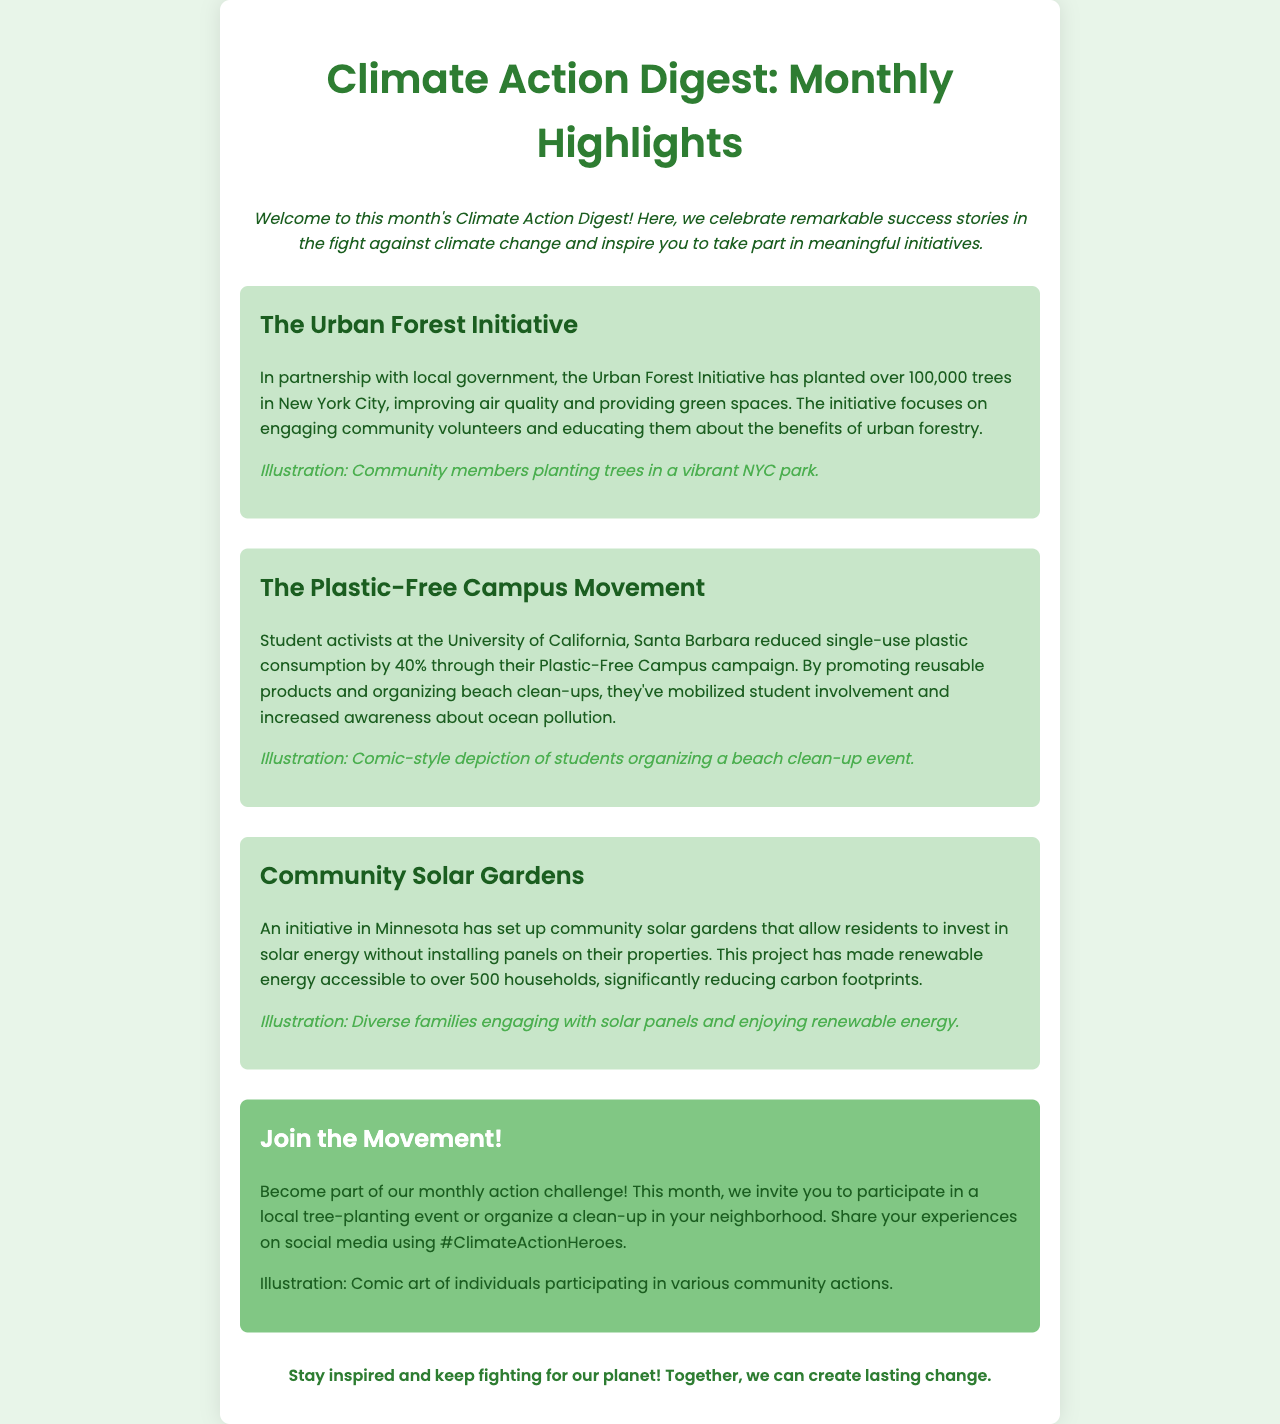What is the title of the newsletter? The title of the newsletter is highlighted at the top of the document, which is "Climate Action Digest: Monthly Highlights."
Answer: Climate Action Digest: Monthly Highlights How many trees have been planted in the Urban Forest Initiative? The Urban Forest Initiative states that they have planted over 100,000 trees in New York City.
Answer: 100,000 What is the percentage reduction in single-use plastic consumption by the Plastic-Free Campus Movement? The document mentions that the Plastic-Free Campus campaign has reduced single-use plastic consumption by 40%.
Answer: 40% What initiative has made renewable energy accessible to over 500 households? The document highlights the community solar gardens initiative in Minnesota that has provided access to renewable energy for over 500 households.
Answer: Community Solar Gardens What is the main call-to-action for this month? The call-to-action encourages participation in a local tree-planting event or organizing a neighborhood clean-up.
Answer: Tree-planting event Which university is associated with the Plastic-Free Campus campaign? The document specifies that the Plastic-Free Campus campaign is associated with the University of California, Santa Barbara.
Answer: University of California, Santa Barbara What is the color scheme of the newsletter? The color scheme includes a background of light green (#E8F5E9) and text in dark green (#1B5E20), creating a nature-inspired aesthetic.
Answer: Light green and dark green What illustration style is mentioned for students organizing a beach clean-up event? The illustration style for the beach clean-up event is described as "comic-style depiction."
Answer: Comic-style depiction 